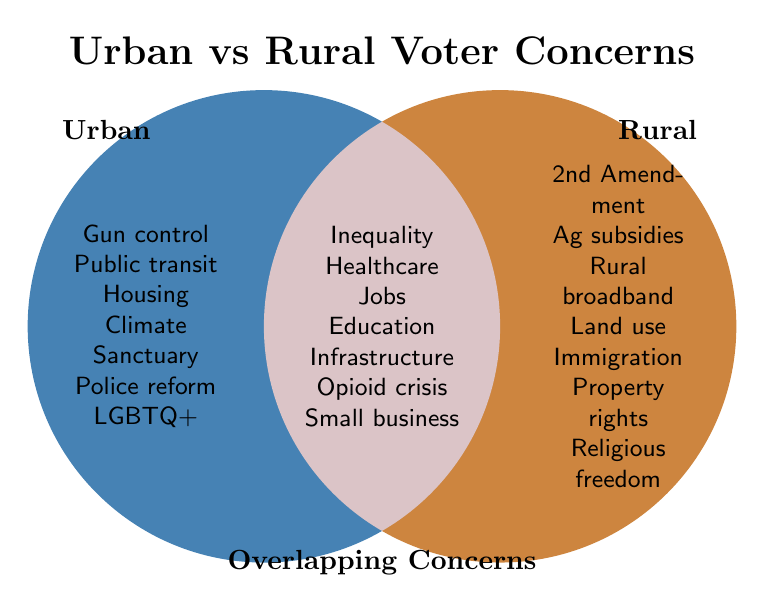What are two unique concerns of urban voters? From the left circle labeled "Urban", two unique concerns listed are "Gun control" and "Public transportation".
Answer: Gun control, Public transportation What is the common concern related to health in both urban and rural areas? In the overlapping section labeled "Both", the concern related to health is "Healthcare access".
Answer: Healthcare access Which concerns belong exclusively to rural voters regarding technology? In the right circle labeled "Rural", the concern related to technology is "Rural broadband".
Answer: Rural broadband Are there more unique concerns for urban or rural voters? Count the concerns in each circle. Urban has 7, Rural has 7, and Both has 7 concerns. Urban and Rural have the same number of unique concerns.
Answer: Same number What is one concern that affects both urban and rural voters related to the economy? In the overlapping section labeled "Both", the economic-related concerns include "Economic inequality", "Job creation" and "Small business support". Any one of these can be an answer.
Answer: Economic inequality (or Job creation, or Small business support) How many total concerns are listed for both urban and rural areas combined, excluding overlaps? Count the distinct concerns in both circles minus the overlapping ones. Urban has 7, Rural has 7. Hence, 7 (Urban) + 7 (Rural) - 7 (Both) = 7 + 7 - 7 = 7 + 0 = 14.
Answer: 14 concerns Name one concern in each category (Urban, Rural, Both) related to regulations. Urban: "Climate change policies", Rural: "Land use regulations", Both: "Infrastructure improvement".
Answer: Climate change policies, Land use regulations, Infrastructure improvement Which category has a higher number of shared concerns: Urban or Rural? The overlapping section labeled "Both" has 7 concerns shared between Urban and Rural voters. Comparatively, both Urban and Rural have 7 unique concerns each. They share an equal number of concerns.
Answer: Equal What is a shared concern related to social issues in both urban and rural communities? In the overlapping section labeled "Both", a social issue is "Education funding".
Answer: Education funding 